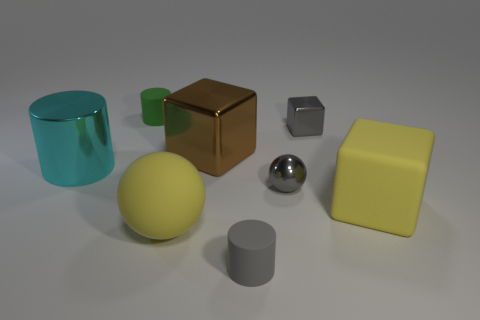How many other things are the same size as the yellow cube?
Provide a succinct answer. 3. The matte object that is behind the tiny ball is what color?
Keep it short and to the point. Green. Do the block to the left of the gray rubber thing and the yellow block have the same material?
Your answer should be compact. No. What number of rubber objects are on the left side of the gray metallic cube and behind the yellow rubber sphere?
Make the answer very short. 1. What is the color of the big object that is to the right of the big brown metal block to the left of the matte cylinder in front of the green rubber cylinder?
Keep it short and to the point. Yellow. What number of other things are the same shape as the brown thing?
Your response must be concise. 2. There is a yellow object that is left of the rubber block; are there any big cubes that are in front of it?
Provide a short and direct response. No. What number of matte things are things or large brown cubes?
Give a very brief answer. 4. There is a object that is both behind the brown cube and on the left side of the tiny gray block; what material is it?
Provide a short and direct response. Rubber. There is a large yellow matte ball in front of the tiny metal thing in front of the large brown thing; is there a tiny metal thing in front of it?
Make the answer very short. No. 